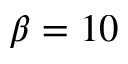Convert formula to latex. <formula><loc_0><loc_0><loc_500><loc_500>\beta = 1 0</formula> 